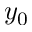Convert formula to latex. <formula><loc_0><loc_0><loc_500><loc_500>y _ { 0 }</formula> 